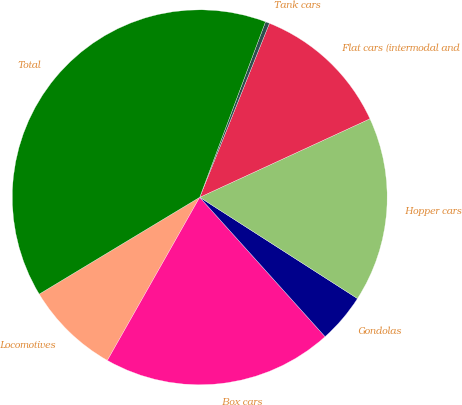<chart> <loc_0><loc_0><loc_500><loc_500><pie_chart><fcel>Locomotives<fcel>Box cars<fcel>Gondolas<fcel>Hopper cars<fcel>Flat cars (intermodal and<fcel>Tank cars<fcel>Total<nl><fcel>8.16%<fcel>19.86%<fcel>4.26%<fcel>15.96%<fcel>12.06%<fcel>0.36%<fcel>39.35%<nl></chart> 